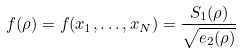<formula> <loc_0><loc_0><loc_500><loc_500>f ( \rho ) = f ( x _ { 1 } , \dots , x _ { N } ) = \frac { S _ { 1 } ( \rho ) } { \sqrt { e _ { 2 } ( \rho ) } }</formula> 